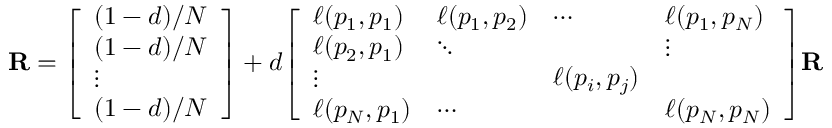Convert formula to latex. <formula><loc_0><loc_0><loc_500><loc_500>R = { \left [ \begin{array} { l } { ( 1 - d ) / N } \\ { ( 1 - d ) / N } \\ { \vdots } \\ { ( 1 - d ) / N } \end{array} \right ] } + d { \left [ \begin{array} { l l l l } { \ell ( p _ { 1 } , p _ { 1 } ) } & { \ell ( p _ { 1 } , p _ { 2 } ) } & { \cdots } & { \ell ( p _ { 1 } , p _ { N } ) } \\ { \ell ( p _ { 2 } , p _ { 1 } ) } & { \ddots } & & { \vdots } \\ { \vdots } & & { \ell ( p _ { i } , p _ { j } ) } & \\ { \ell ( p _ { N } , p _ { 1 } ) } & { \cdots } & & { \ell ( p _ { N } , p _ { N } ) } \end{array} \right ] } R</formula> 